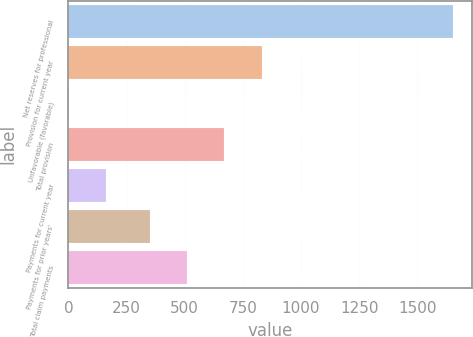Convert chart to OTSL. <chart><loc_0><loc_0><loc_500><loc_500><bar_chart><fcel>Net reserves for professional<fcel>Provision for current year<fcel>Unfavorable (favorable)<fcel>Total provision<fcel>Payments for current year<fcel>Payments for prior years'<fcel>Total claim payments<nl><fcel>1654.2<fcel>830.6<fcel>1<fcel>670.4<fcel>161.2<fcel>350<fcel>510.2<nl></chart> 